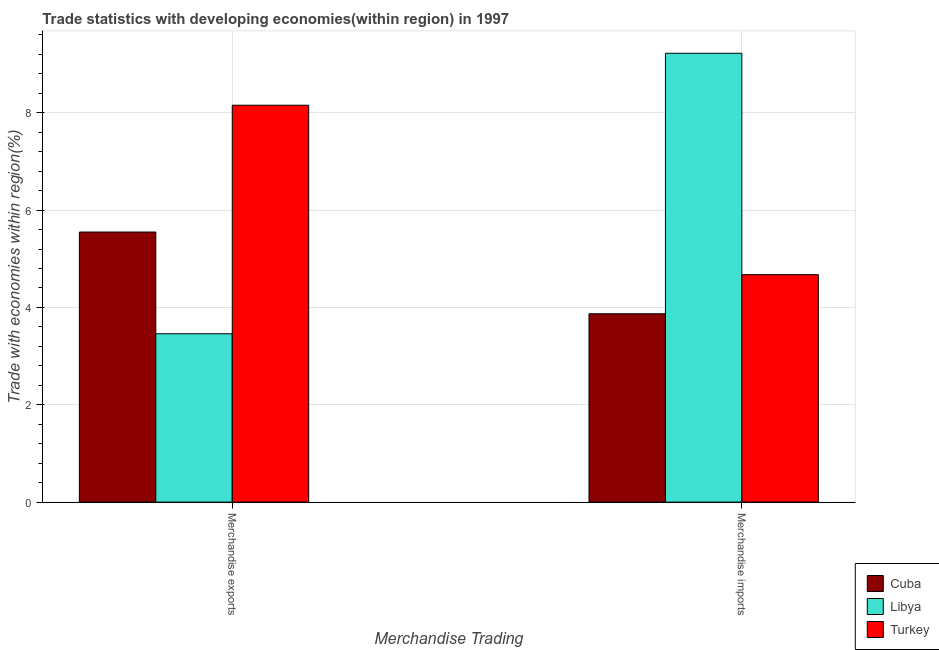Are the number of bars per tick equal to the number of legend labels?
Ensure brevity in your answer.  Yes. What is the label of the 2nd group of bars from the left?
Provide a short and direct response. Merchandise imports. What is the merchandise imports in Turkey?
Provide a succinct answer. 4.67. Across all countries, what is the maximum merchandise exports?
Provide a succinct answer. 8.15. Across all countries, what is the minimum merchandise exports?
Provide a succinct answer. 3.46. In which country was the merchandise exports minimum?
Provide a short and direct response. Libya. What is the total merchandise exports in the graph?
Ensure brevity in your answer.  17.16. What is the difference between the merchandise exports in Libya and that in Cuba?
Your answer should be very brief. -2.09. What is the difference between the merchandise imports in Turkey and the merchandise exports in Libya?
Give a very brief answer. 1.21. What is the average merchandise exports per country?
Keep it short and to the point. 5.72. What is the difference between the merchandise imports and merchandise exports in Cuba?
Offer a terse response. -1.68. What is the ratio of the merchandise exports in Turkey to that in Cuba?
Offer a very short reply. 1.47. Is the merchandise imports in Turkey less than that in Libya?
Provide a short and direct response. Yes. What does the 2nd bar from the left in Merchandise exports represents?
Your response must be concise. Libya. What does the 3rd bar from the right in Merchandise exports represents?
Keep it short and to the point. Cuba. How many countries are there in the graph?
Keep it short and to the point. 3. Are the values on the major ticks of Y-axis written in scientific E-notation?
Your answer should be very brief. No. Does the graph contain grids?
Offer a terse response. Yes. What is the title of the graph?
Your answer should be very brief. Trade statistics with developing economies(within region) in 1997. What is the label or title of the X-axis?
Ensure brevity in your answer.  Merchandise Trading. What is the label or title of the Y-axis?
Keep it short and to the point. Trade with economies within region(%). What is the Trade with economies within region(%) of Cuba in Merchandise exports?
Offer a very short reply. 5.55. What is the Trade with economies within region(%) in Libya in Merchandise exports?
Make the answer very short. 3.46. What is the Trade with economies within region(%) in Turkey in Merchandise exports?
Provide a succinct answer. 8.15. What is the Trade with economies within region(%) in Cuba in Merchandise imports?
Your answer should be very brief. 3.87. What is the Trade with economies within region(%) of Libya in Merchandise imports?
Offer a very short reply. 9.22. What is the Trade with economies within region(%) in Turkey in Merchandise imports?
Provide a succinct answer. 4.67. Across all Merchandise Trading, what is the maximum Trade with economies within region(%) of Cuba?
Provide a succinct answer. 5.55. Across all Merchandise Trading, what is the maximum Trade with economies within region(%) in Libya?
Your answer should be very brief. 9.22. Across all Merchandise Trading, what is the maximum Trade with economies within region(%) of Turkey?
Give a very brief answer. 8.15. Across all Merchandise Trading, what is the minimum Trade with economies within region(%) in Cuba?
Provide a succinct answer. 3.87. Across all Merchandise Trading, what is the minimum Trade with economies within region(%) of Libya?
Make the answer very short. 3.46. Across all Merchandise Trading, what is the minimum Trade with economies within region(%) in Turkey?
Your answer should be compact. 4.67. What is the total Trade with economies within region(%) in Cuba in the graph?
Keep it short and to the point. 9.42. What is the total Trade with economies within region(%) of Libya in the graph?
Provide a succinct answer. 12.68. What is the total Trade with economies within region(%) of Turkey in the graph?
Keep it short and to the point. 12.83. What is the difference between the Trade with economies within region(%) in Cuba in Merchandise exports and that in Merchandise imports?
Provide a short and direct response. 1.68. What is the difference between the Trade with economies within region(%) of Libya in Merchandise exports and that in Merchandise imports?
Your answer should be very brief. -5.76. What is the difference between the Trade with economies within region(%) of Turkey in Merchandise exports and that in Merchandise imports?
Provide a succinct answer. 3.48. What is the difference between the Trade with economies within region(%) of Cuba in Merchandise exports and the Trade with economies within region(%) of Libya in Merchandise imports?
Give a very brief answer. -3.67. What is the difference between the Trade with economies within region(%) of Cuba in Merchandise exports and the Trade with economies within region(%) of Turkey in Merchandise imports?
Make the answer very short. 0.88. What is the difference between the Trade with economies within region(%) in Libya in Merchandise exports and the Trade with economies within region(%) in Turkey in Merchandise imports?
Your answer should be compact. -1.21. What is the average Trade with economies within region(%) of Cuba per Merchandise Trading?
Provide a short and direct response. 4.71. What is the average Trade with economies within region(%) in Libya per Merchandise Trading?
Provide a succinct answer. 6.34. What is the average Trade with economies within region(%) of Turkey per Merchandise Trading?
Ensure brevity in your answer.  6.41. What is the difference between the Trade with economies within region(%) in Cuba and Trade with economies within region(%) in Libya in Merchandise exports?
Keep it short and to the point. 2.09. What is the difference between the Trade with economies within region(%) in Cuba and Trade with economies within region(%) in Turkey in Merchandise exports?
Keep it short and to the point. -2.61. What is the difference between the Trade with economies within region(%) in Libya and Trade with economies within region(%) in Turkey in Merchandise exports?
Offer a terse response. -4.69. What is the difference between the Trade with economies within region(%) of Cuba and Trade with economies within region(%) of Libya in Merchandise imports?
Ensure brevity in your answer.  -5.35. What is the difference between the Trade with economies within region(%) of Cuba and Trade with economies within region(%) of Turkey in Merchandise imports?
Provide a succinct answer. -0.8. What is the difference between the Trade with economies within region(%) in Libya and Trade with economies within region(%) in Turkey in Merchandise imports?
Your answer should be compact. 4.55. What is the ratio of the Trade with economies within region(%) in Cuba in Merchandise exports to that in Merchandise imports?
Provide a short and direct response. 1.43. What is the ratio of the Trade with economies within region(%) in Libya in Merchandise exports to that in Merchandise imports?
Your answer should be very brief. 0.38. What is the ratio of the Trade with economies within region(%) of Turkey in Merchandise exports to that in Merchandise imports?
Provide a short and direct response. 1.75. What is the difference between the highest and the second highest Trade with economies within region(%) of Cuba?
Make the answer very short. 1.68. What is the difference between the highest and the second highest Trade with economies within region(%) in Libya?
Your answer should be very brief. 5.76. What is the difference between the highest and the second highest Trade with economies within region(%) of Turkey?
Offer a terse response. 3.48. What is the difference between the highest and the lowest Trade with economies within region(%) of Cuba?
Make the answer very short. 1.68. What is the difference between the highest and the lowest Trade with economies within region(%) of Libya?
Keep it short and to the point. 5.76. What is the difference between the highest and the lowest Trade with economies within region(%) in Turkey?
Offer a terse response. 3.48. 